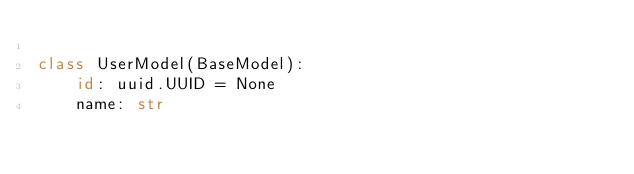Convert code to text. <code><loc_0><loc_0><loc_500><loc_500><_Python_>
class UserModel(BaseModel):
    id: uuid.UUID = None
    name: str
</code> 